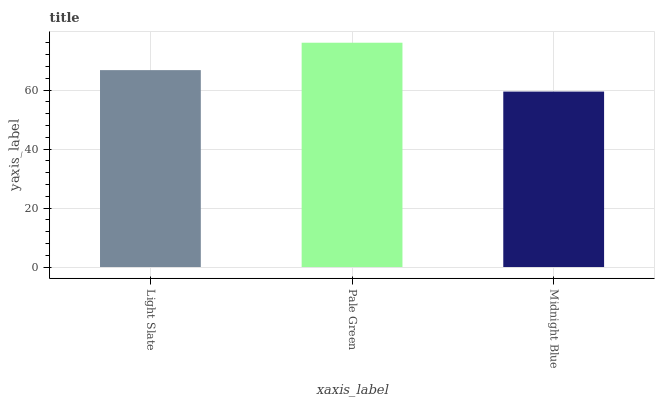Is Pale Green the maximum?
Answer yes or no. Yes. Is Pale Green the minimum?
Answer yes or no. No. Is Midnight Blue the maximum?
Answer yes or no. No. Is Pale Green greater than Midnight Blue?
Answer yes or no. Yes. Is Midnight Blue less than Pale Green?
Answer yes or no. Yes. Is Midnight Blue greater than Pale Green?
Answer yes or no. No. Is Pale Green less than Midnight Blue?
Answer yes or no. No. Is Light Slate the high median?
Answer yes or no. Yes. Is Light Slate the low median?
Answer yes or no. Yes. Is Pale Green the high median?
Answer yes or no. No. Is Pale Green the low median?
Answer yes or no. No. 